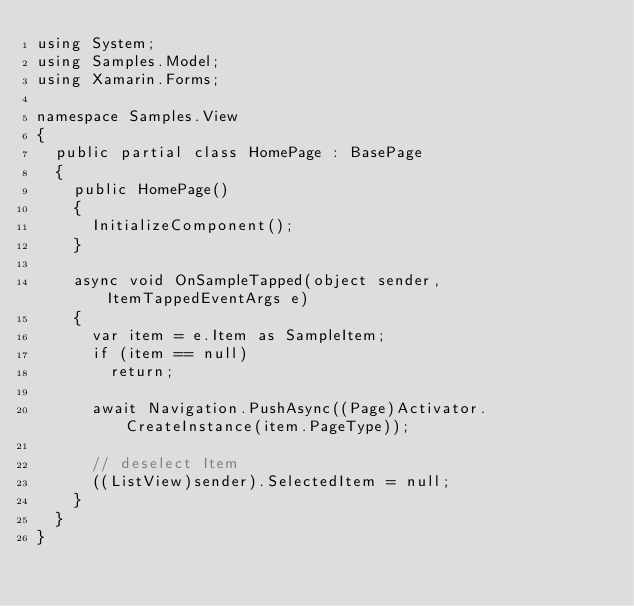Convert code to text. <code><loc_0><loc_0><loc_500><loc_500><_C#_>using System;
using Samples.Model;
using Xamarin.Forms;

namespace Samples.View
{
	public partial class HomePage : BasePage
	{
		public HomePage()
		{
			InitializeComponent();
		}

		async void OnSampleTapped(object sender, ItemTappedEventArgs e)
		{
			var item = e.Item as SampleItem;
			if (item == null)
				return;

			await Navigation.PushAsync((Page)Activator.CreateInstance(item.PageType));

			// deselect Item
			((ListView)sender).SelectedItem = null;
		}
	}
}
</code> 